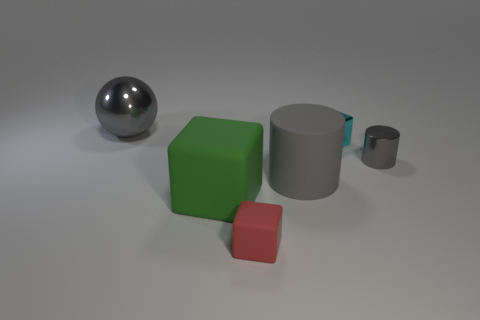What size is the other shiny thing that is the same color as the big metal thing?
Provide a short and direct response. Small. Is the green object the same size as the gray ball?
Ensure brevity in your answer.  Yes. There is a gray thing that is both in front of the big shiny thing and on the left side of the tiny cylinder; how big is it?
Provide a short and direct response. Large. How many large balls are made of the same material as the small cylinder?
Provide a succinct answer. 1. There is a big matte thing that is the same color as the shiny cylinder; what shape is it?
Keep it short and to the point. Cylinder. The big cube is what color?
Provide a succinct answer. Green. There is a big gray thing that is on the right side of the big gray shiny thing; is its shape the same as the tiny cyan metal object?
Make the answer very short. No. How many things are metal objects behind the small gray metallic object or tiny yellow rubber cylinders?
Make the answer very short. 2. Is there a large gray thing that has the same shape as the tiny gray object?
Your answer should be compact. Yes. The gray matte object that is the same size as the green rubber object is what shape?
Your answer should be compact. Cylinder. 